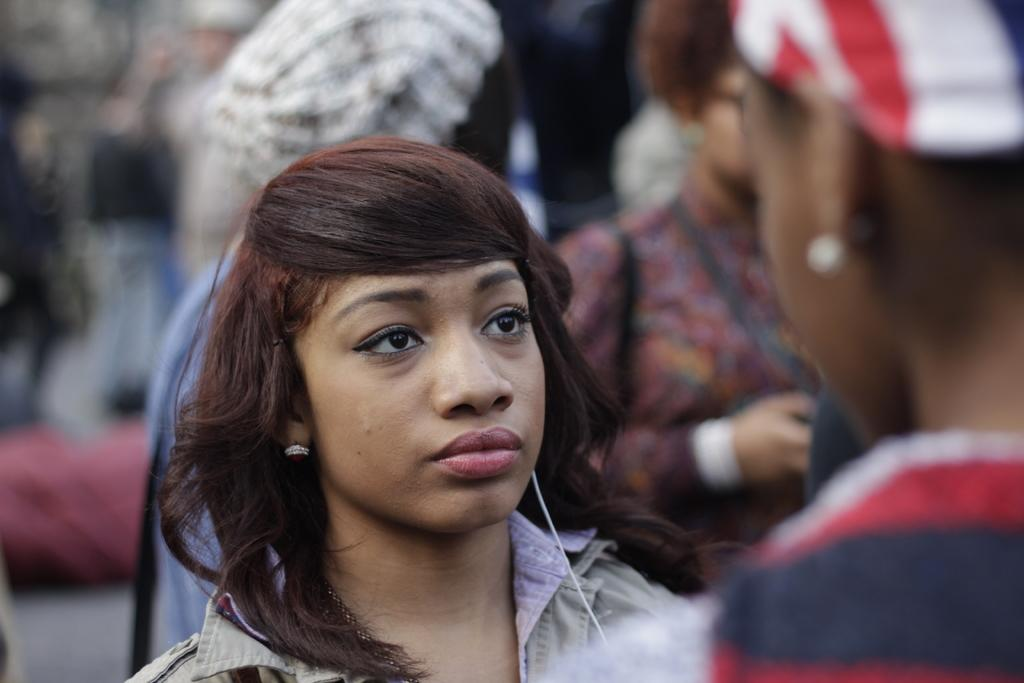Who is the main subject in the image? There is a woman in the image. What can be seen in the image besides the woman? There is a cable and a blurred background visible in the image. Are there any other people in the image? Yes, there are few persons visible in the background and another person on the right side of the image. What type of slope can be seen in the image? There is no slope present in the image. What team is the woman representing in the image? The image does not provide any information about a team or any representation. 